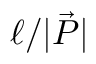Convert formula to latex. <formula><loc_0><loc_0><loc_500><loc_500>\ell / | \vec { P } |</formula> 